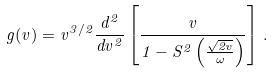Convert formula to latex. <formula><loc_0><loc_0><loc_500><loc_500>g ( v ) = v ^ { 3 / 2 } \frac { d ^ { 2 } } { d v ^ { 2 } } \left [ \frac { v } { 1 - S ^ { 2 } \left ( \frac { \sqrt { 2 v } } { \omega } \right ) } \right ] \, .</formula> 